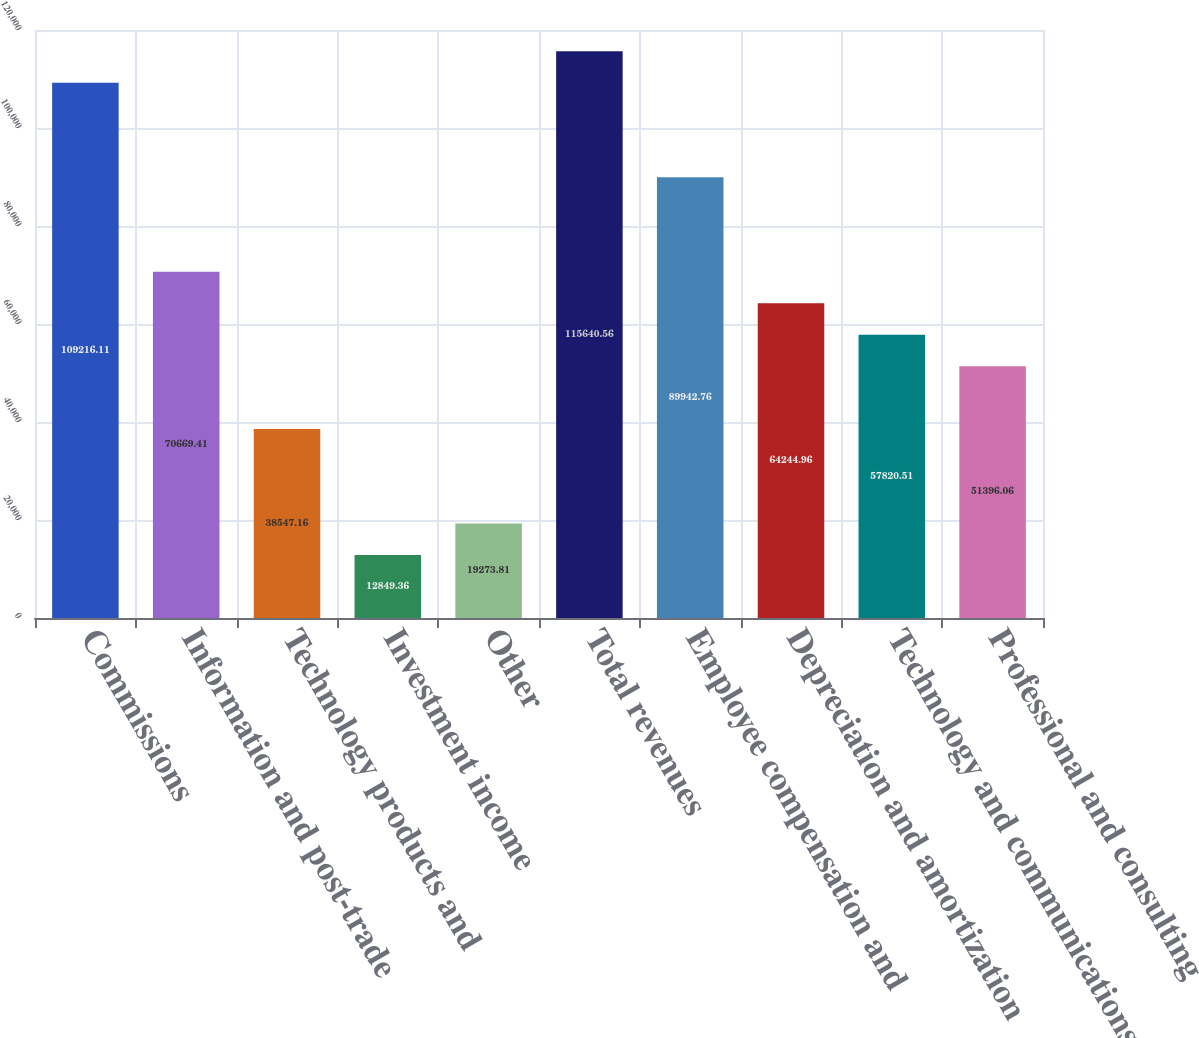Convert chart. <chart><loc_0><loc_0><loc_500><loc_500><bar_chart><fcel>Commissions<fcel>Information and post-trade<fcel>Technology products and<fcel>Investment income<fcel>Other<fcel>Total revenues<fcel>Employee compensation and<fcel>Depreciation and amortization<fcel>Technology and communications<fcel>Professional and consulting<nl><fcel>109216<fcel>70669.4<fcel>38547.2<fcel>12849.4<fcel>19273.8<fcel>115641<fcel>89942.8<fcel>64245<fcel>57820.5<fcel>51396.1<nl></chart> 